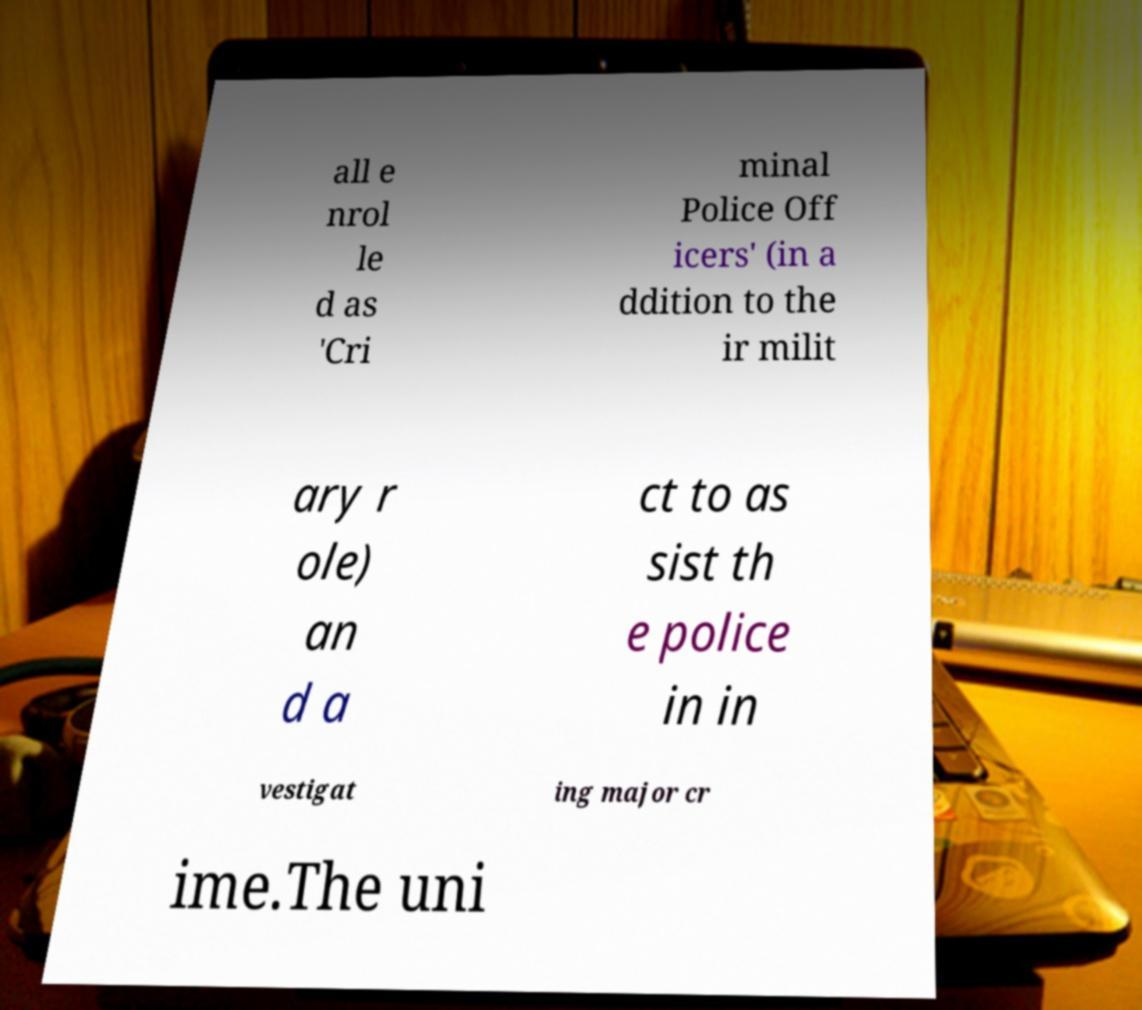There's text embedded in this image that I need extracted. Can you transcribe it verbatim? all e nrol le d as 'Cri minal Police Off icers' (in a ddition to the ir milit ary r ole) an d a ct to as sist th e police in in vestigat ing major cr ime.The uni 